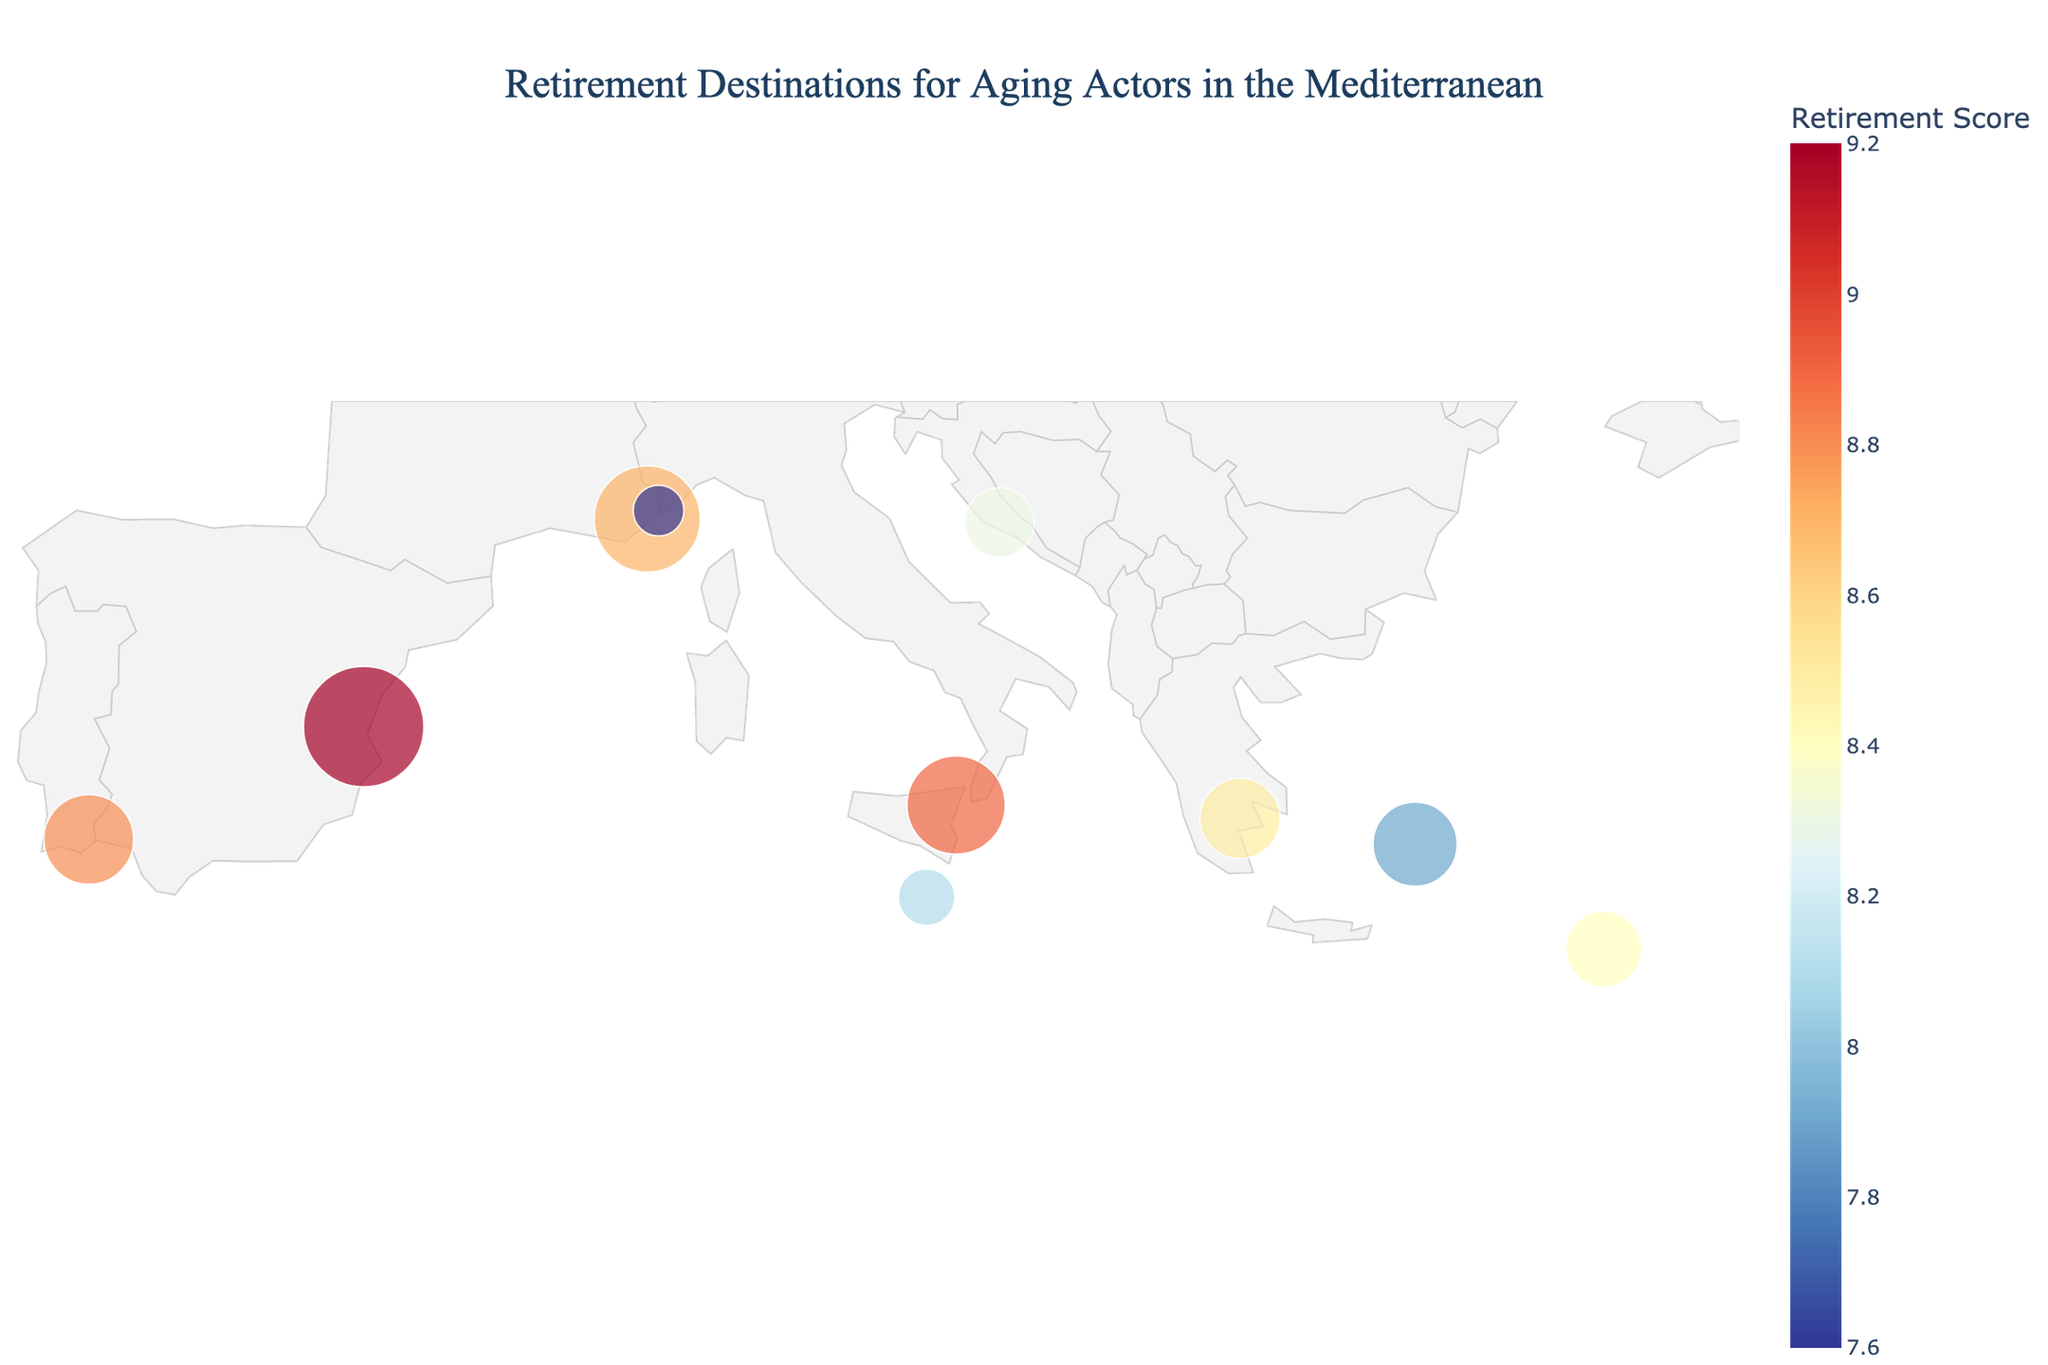What is the title of the plot? The title of the plot is indicated at the top and reads "Retirement Destinations for Aging Actors in the Mediterranean".
Answer: Retirement Destinations for Aging Actors in the Mediterranean How many cities are shown in the plot? You can determine the number of cities by counting the markers represented on the geographic plot. There are 10 markers indicating 10 different cities.
Answer: 10 Which city has the highest retirement score? To find the city with the highest retirement score, look at the marker with the darkest color, since the color intensity represents the Retirement Score. Valencia in Spain has the highest score of 9.2.
Answer: Valencia What is the average Retirement Score of all the cities? To calculate the average Retirement Score, sum up all the scores and divide by the number of cities. The sum is 9.2 + 8.9 + 8.5 + 8.7 + 8.3 + 8.8 + 8.1 + 8.4 + 7.9 + 7.6 = 84.4, and the average is 84.4 / 10 = 8.44.
Answer: 8.44 Which city has the lowest Cost of Living, and what is its value? By finding the city with the smallest size in the Cost of Living data from the hover info, one can observe that Bodrum in Turkey has the lowest Cost of Living value of 50.
Answer: Bodrum, 50 How does the Theatre Opportunities compare between Valencia and Monte Carlo? By observing the sizes and hover info, Valencia has 8 Theatre Opportunities, while Monte Carlo also has 8 Theatre Opportunities. Both have an equal number of Theatre Opportunities.
Answer: Equal (8) What are the coordinates (latitude and longitude) of Split, Croatia? By looking at the data that maps the cities to their coordinates, Split has coordinates (43.51, 16.44).
Answer: 43.51, 16.44 Can you list the cities in descending order of their Actor Population? To list the cities by Actor Population, sort the cities by the size of their markers from largest to smallest. Valencia (450), Antibes (350), Taormina (300), Tavira (250), Bodrum (220), Paphos (180), Nafplio (200), Split (150), Valletta (100), Monte Carlo (80).
Answer: Valencia, Antibes, Taormina, Tavira, Bodrum, Paphos, Nafplio, Split, Valletta, Monte Carlo What is the difference in Cost of Living between Antibes and Tavira? The Cost of Living of Antibes is 85, while Tavira is 55. Subtracting these numbers gives 85 - 55 = 30.
Answer: 30 If you want to find a city with a moderate Actor Population (around the median), what would be an example and its Actor Population? Sorting the Actor Population values: 80, 100, 150, 180, 200, 220, 250, 300, 350, 450. The median Actor Population would be the average of the two middle values 220 (Bodrum) and 250 (Tavira), which is 235. An example near this median would be Bodrum with 220 or Tavira with 250.
Answer: Bodrum, 220 Which city provides the best balance between Cost of Living and Retirement Score, and why? A good balance would consider a lower Cost of Living and a higher Retirement Score. Bodrum has the lowest Cost of Living (50) but a moderate Retirement Score (7.9). Tavira could be considered the best balance with a low Cost of Living (55) and a high Retirement Score (8.8).
Answer: Tavira, balance 